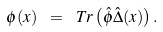Convert formula to latex. <formula><loc_0><loc_0><loc_500><loc_500>\phi ( x ) \ = \ T r \left ( \hat { \phi } \hat { \Delta } ( x ) \right ) .</formula> 